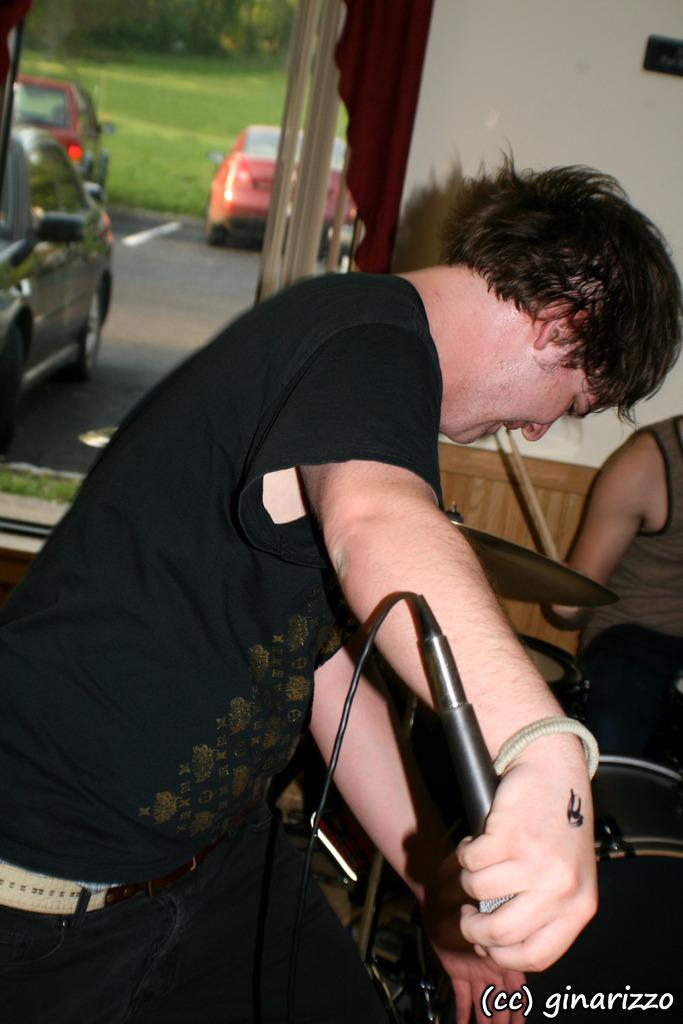What is the person in the foreground of the image doing? The person is standing and holding a microphone. What can be seen in the background of the image? There is a wall, cars on the road, and grass visible in the background. What is the second person in the image doing? The second person is sitting and holding a musical instrument. What type of weather is depicted in the image? The provided facts do not mention any weather conditions, so it cannot be determined from the image. What holiday is being celebrated in the image? There is no indication of a holiday being celebrated in the image. 